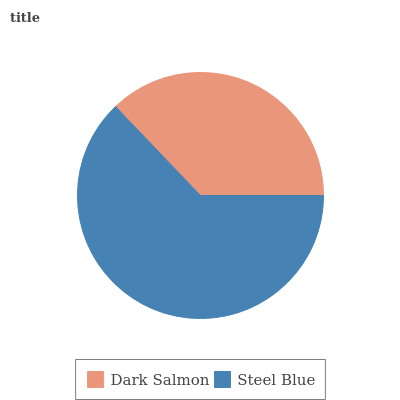Is Dark Salmon the minimum?
Answer yes or no. Yes. Is Steel Blue the maximum?
Answer yes or no. Yes. Is Steel Blue the minimum?
Answer yes or no. No. Is Steel Blue greater than Dark Salmon?
Answer yes or no. Yes. Is Dark Salmon less than Steel Blue?
Answer yes or no. Yes. Is Dark Salmon greater than Steel Blue?
Answer yes or no. No. Is Steel Blue less than Dark Salmon?
Answer yes or no. No. Is Steel Blue the high median?
Answer yes or no. Yes. Is Dark Salmon the low median?
Answer yes or no. Yes. Is Dark Salmon the high median?
Answer yes or no. No. Is Steel Blue the low median?
Answer yes or no. No. 